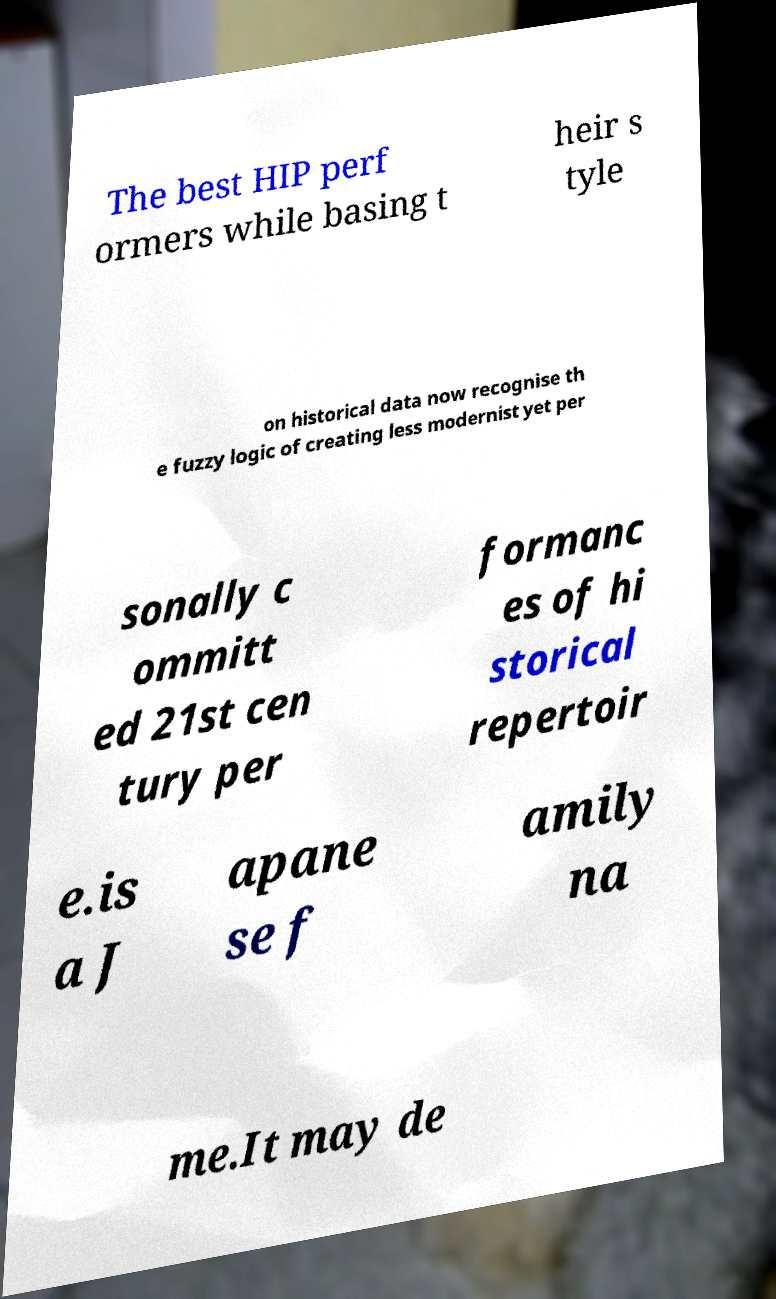Please identify and transcribe the text found in this image. The best HIP perf ormers while basing t heir s tyle on historical data now recognise th e fuzzy logic of creating less modernist yet per sonally c ommitt ed 21st cen tury per formanc es of hi storical repertoir e.is a J apane se f amily na me.It may de 